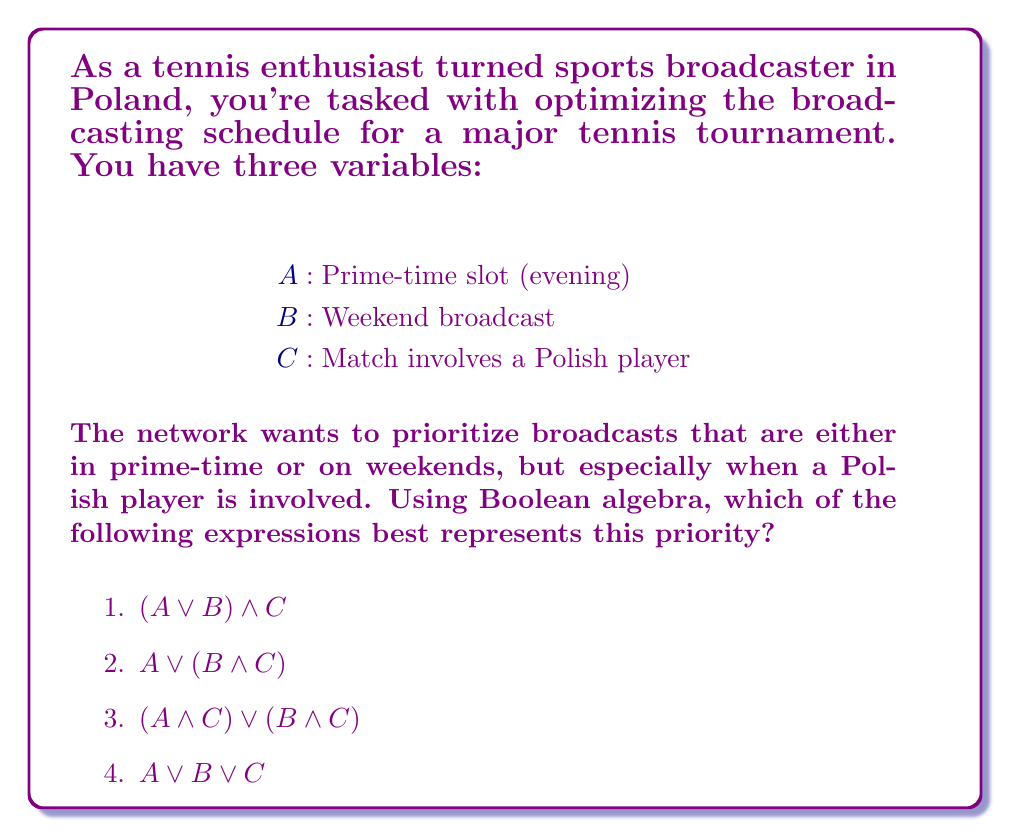Provide a solution to this math problem. Let's approach this step-by-step using Boolean algebra:

1) First, we need to understand what the network wants:
   - Prioritize prime-time or weekend broadcasts
   - Especially prioritize when a Polish player is involved

2) This can be translated to:
   (Prime-time OR Weekend) AND (Polish player if possible)

3) In Boolean terms:
   $(A \lor B)$ represents "Prime-time OR Weekend"
   $C$ represents "Polish player involved"

4) To combine these, we use the AND operator:
   $(A \lor B) \land C$

5) This expression means:
   "Broadcast if it's prime-time or weekend, but only if a Polish player is involved"

6) However, this is too restrictive. We want to broadcast prime-time or weekend matches even if a Polish player isn't involved, but we want to especially prioritize Polish players.

7) The correct expression should allow for:
   - Prime-time broadcasts (with or without Polish players)
   - Weekend broadcasts (with or without Polish players)
   - Any broadcast with Polish players

8) This is best represented by:
   $A \lor B \lor C$

9) This expression means:
   "Broadcast if it's prime-time OR if it's on the weekend OR if a Polish player is involved"

This accurately reflects the network's priorities while not being overly restrictive.
Answer: 4) $A \lor B \lor C$ 